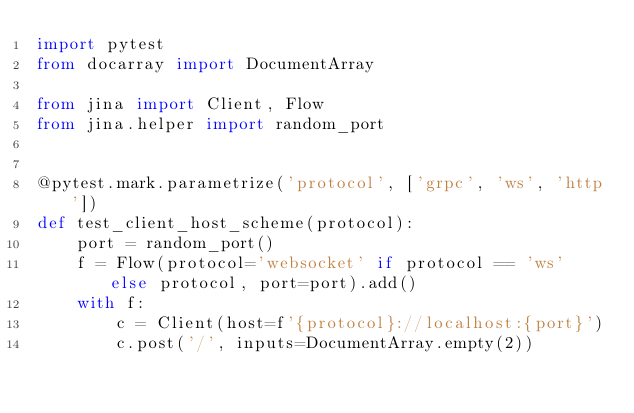Convert code to text. <code><loc_0><loc_0><loc_500><loc_500><_Python_>import pytest
from docarray import DocumentArray

from jina import Client, Flow
from jina.helper import random_port


@pytest.mark.parametrize('protocol', ['grpc', 'ws', 'http'])
def test_client_host_scheme(protocol):
    port = random_port()
    f = Flow(protocol='websocket' if protocol == 'ws' else protocol, port=port).add()
    with f:
        c = Client(host=f'{protocol}://localhost:{port}')
        c.post('/', inputs=DocumentArray.empty(2))
</code> 